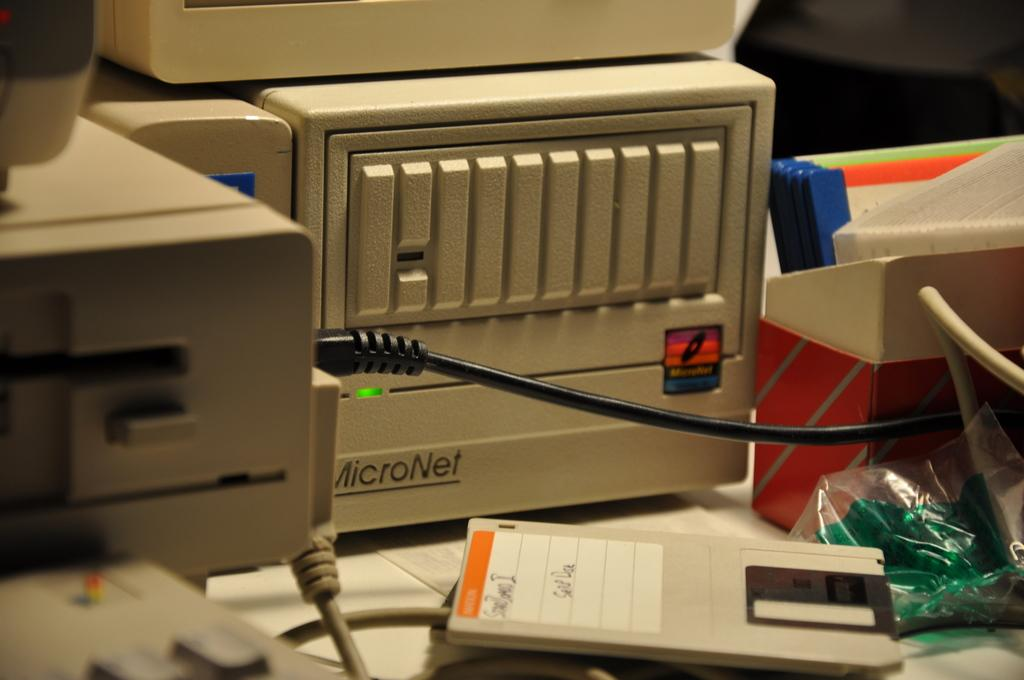<image>
Provide a brief description of the given image. Micronet device next to a gray floppy disc. 